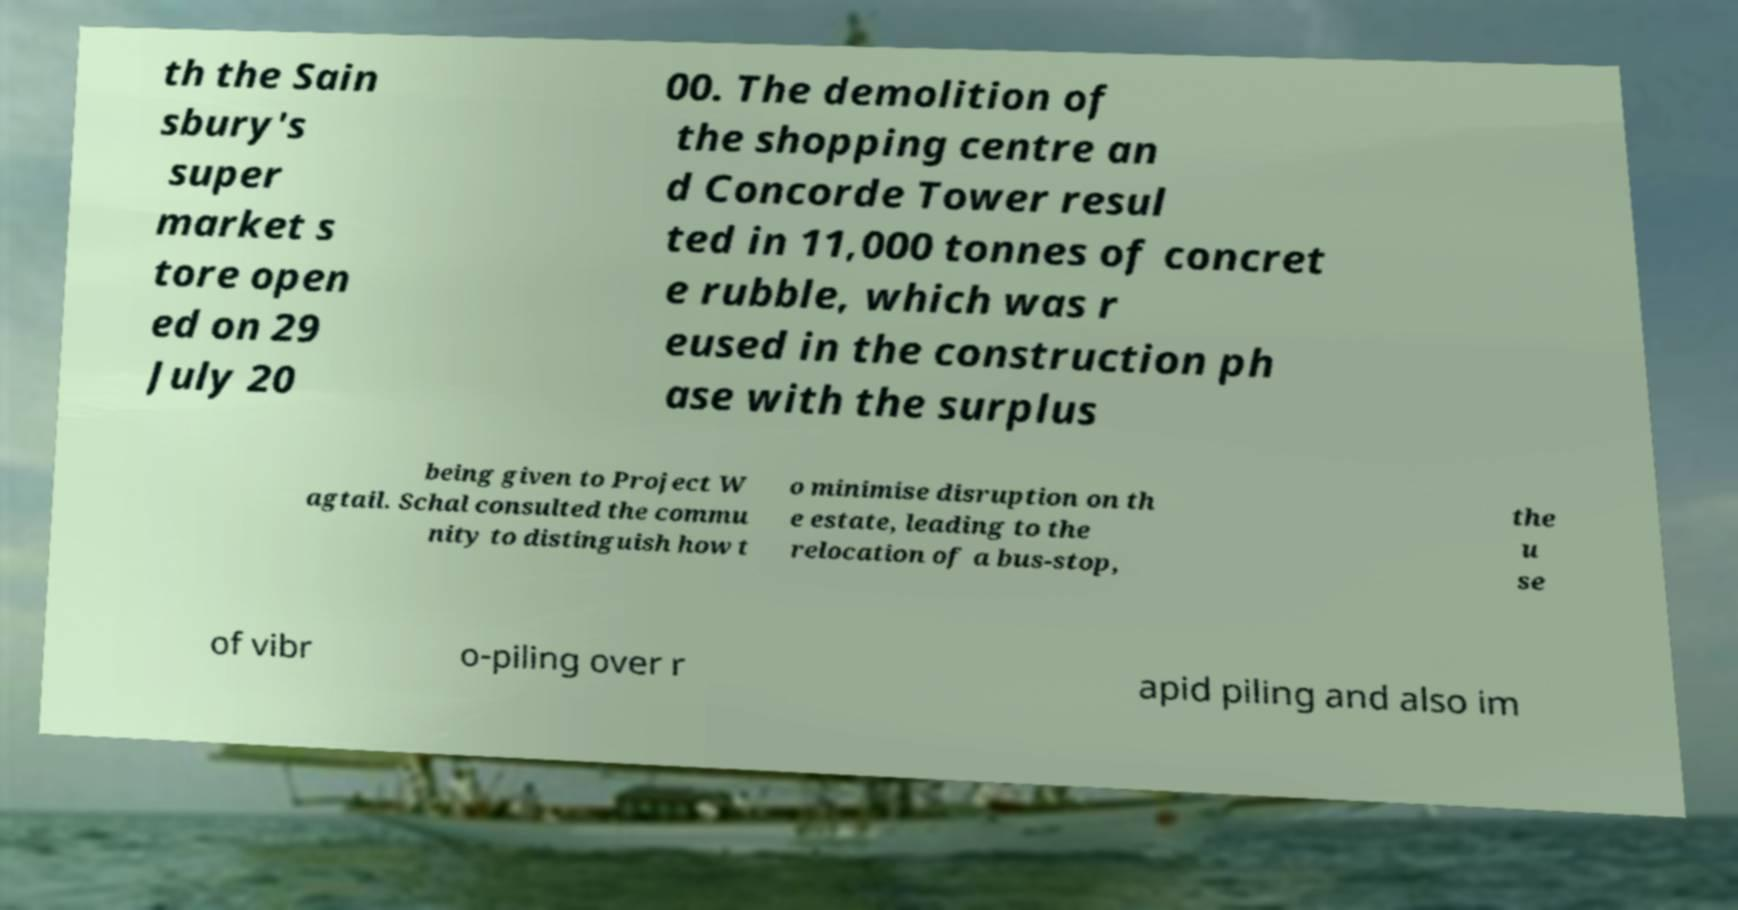There's text embedded in this image that I need extracted. Can you transcribe it verbatim? th the Sain sbury's super market s tore open ed on 29 July 20 00. The demolition of the shopping centre an d Concorde Tower resul ted in 11,000 tonnes of concret e rubble, which was r eused in the construction ph ase with the surplus being given to Project W agtail. Schal consulted the commu nity to distinguish how t o minimise disruption on th e estate, leading to the relocation of a bus-stop, the u se of vibr o-piling over r apid piling and also im 